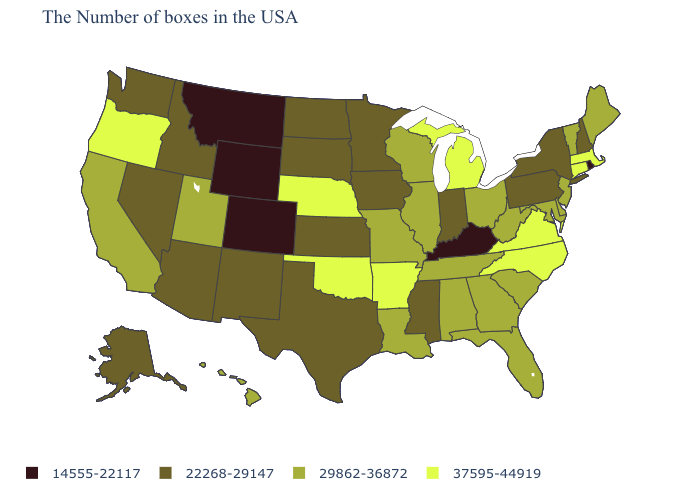Name the states that have a value in the range 29862-36872?
Quick response, please. Maine, Vermont, New Jersey, Delaware, Maryland, South Carolina, West Virginia, Ohio, Florida, Georgia, Alabama, Tennessee, Wisconsin, Illinois, Louisiana, Missouri, Utah, California, Hawaii. How many symbols are there in the legend?
Concise answer only. 4. What is the lowest value in the West?
Concise answer only. 14555-22117. What is the value of Massachusetts?
Concise answer only. 37595-44919. What is the highest value in the USA?
Be succinct. 37595-44919. What is the value of South Carolina?
Give a very brief answer. 29862-36872. Name the states that have a value in the range 29862-36872?
Keep it brief. Maine, Vermont, New Jersey, Delaware, Maryland, South Carolina, West Virginia, Ohio, Florida, Georgia, Alabama, Tennessee, Wisconsin, Illinois, Louisiana, Missouri, Utah, California, Hawaii. Does South Carolina have a lower value than Oklahoma?
Be succinct. Yes. Does Montana have the lowest value in the USA?
Write a very short answer. Yes. Does Kentucky have the lowest value in the USA?
Short answer required. Yes. Does Kentucky have the lowest value in the South?
Short answer required. Yes. Does Rhode Island have a lower value than Montana?
Concise answer only. No. What is the value of Maine?
Answer briefly. 29862-36872. Does Rhode Island have the lowest value in the Northeast?
Quick response, please. Yes. Does South Dakota have a higher value than Kentucky?
Be succinct. Yes. 